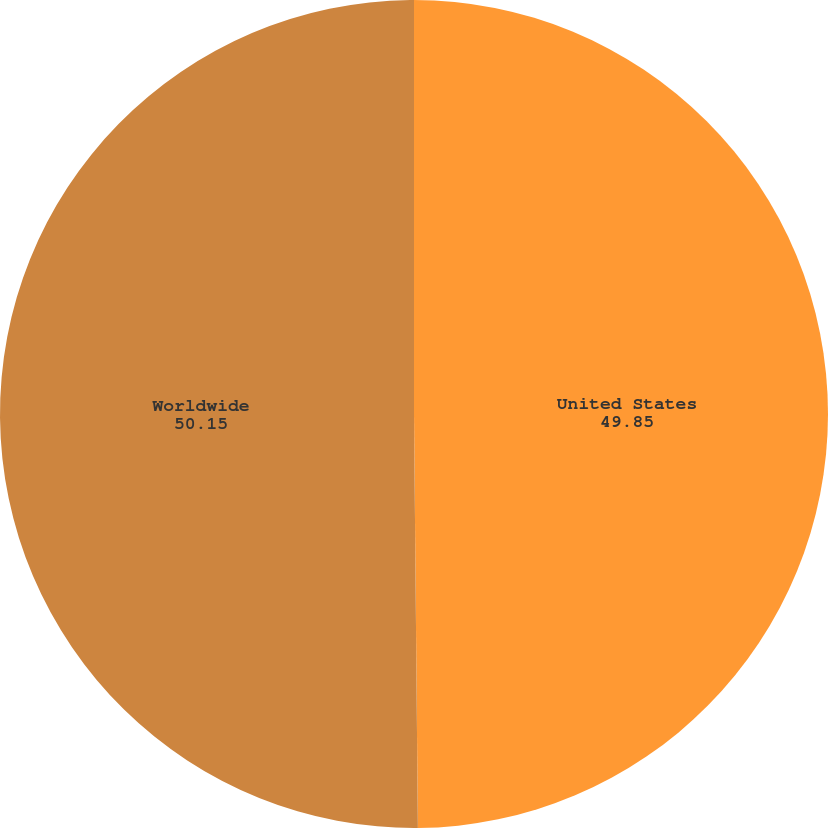Convert chart to OTSL. <chart><loc_0><loc_0><loc_500><loc_500><pie_chart><fcel>United States<fcel>Worldwide<nl><fcel>49.85%<fcel>50.15%<nl></chart> 